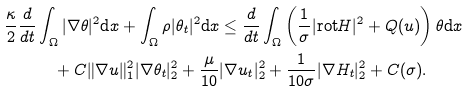<formula> <loc_0><loc_0><loc_500><loc_500>\frac { \kappa } { 2 } \frac { d } { d t } & \int _ { \Omega } | \nabla \theta | ^ { 2 } \text {d} x + \int _ { \Omega } \rho | \theta _ { t } | ^ { 2 } \text {d} x \leq \frac { d } { d t } \int _ { \Omega } \left ( \frac { 1 } { \sigma } | \text {rot} H | ^ { 2 } + Q ( u ) \right ) \theta \text {d} x \\ & \quad + C \| \nabla u \| ^ { 2 } _ { 1 } | \nabla \theta _ { t } | ^ { 2 } _ { 2 } + \frac { \mu } { 1 0 } | \nabla u _ { t } | ^ { 2 } _ { 2 } + \frac { 1 } { 1 0 \sigma } | \nabla H _ { t } | ^ { 2 } _ { 2 } + C ( \sigma ) .</formula> 